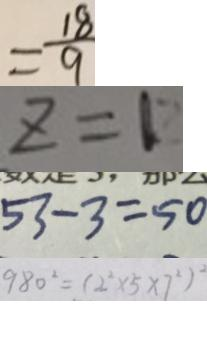Convert formula to latex. <formula><loc_0><loc_0><loc_500><loc_500>= \frac { 1 8 } { 9 } 
 z = 1 
 5 3 - 3 = 5 0 
 9 8 0 ^ { 2 } = ( 2 ^ { 2 } \times 5 \times 7 ^ { 2 } ) ^ { 2 }</formula> 